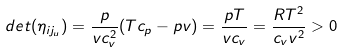<formula> <loc_0><loc_0><loc_500><loc_500>d e t ( \eta _ { i j _ { u } } ) = \frac { p } { v c ^ { 2 } _ { v } } ( T c _ { p } - p v ) = \frac { p T } { v c _ { v } } = \frac { R T ^ { 2 } } { c _ { v } v ^ { 2 } } > 0</formula> 